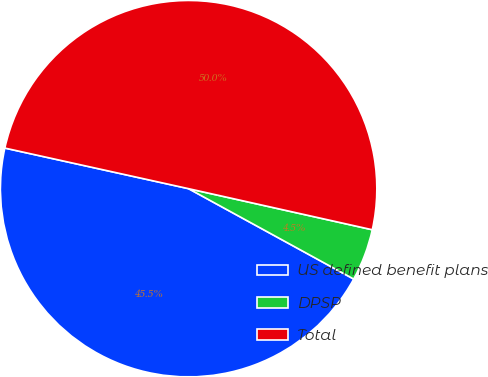<chart> <loc_0><loc_0><loc_500><loc_500><pie_chart><fcel>US defined benefit plans<fcel>DPSP<fcel>Total<nl><fcel>45.49%<fcel>4.47%<fcel>50.04%<nl></chart> 